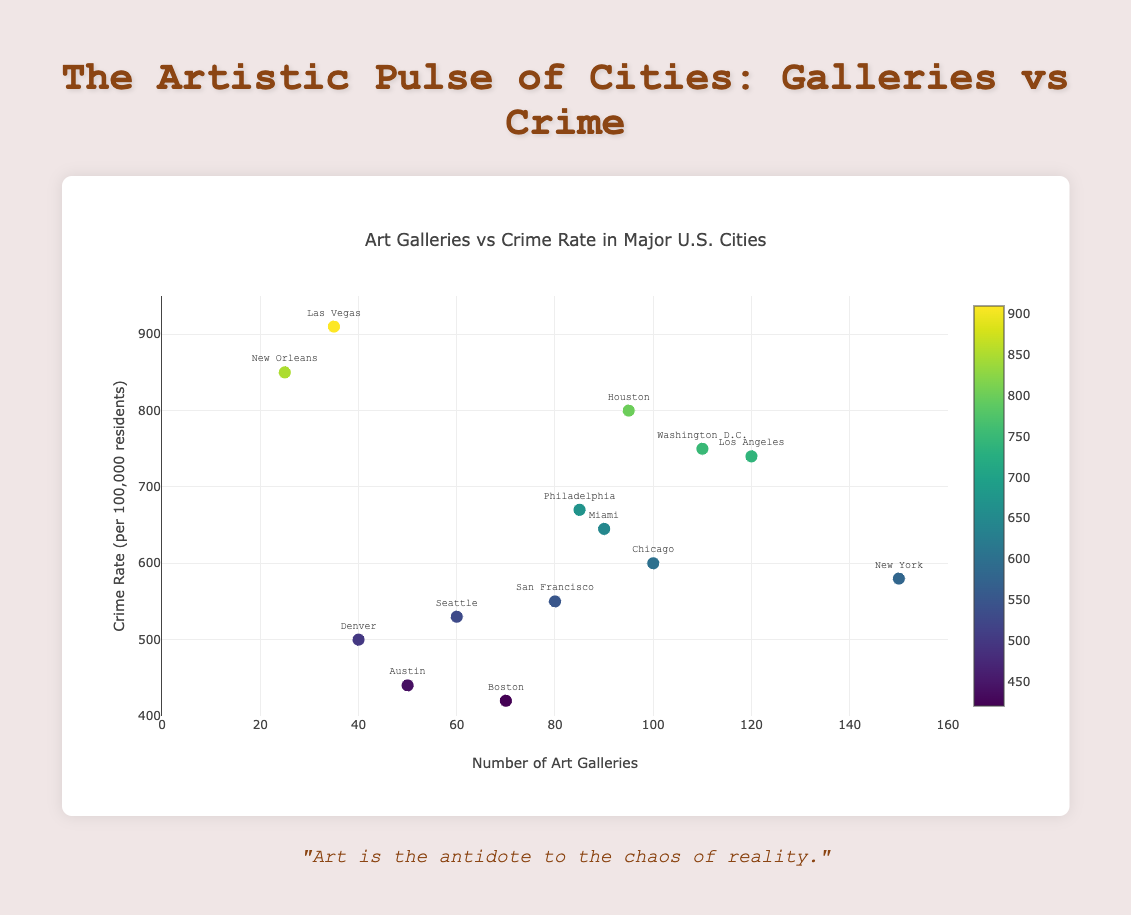What is the title of the plot? The title of the plot is generally located at the top of the figure and provides an overview of what the data represents.
Answer: Art Galleries vs Crime Rate in Major U.S. Cities Which city has the highest crime rate? By looking at the y-axis in the figure and identifying the highest point, then cross-referencing the associated city, you can determine which city has the highest crime rate.
Answer: Las Vegas How many art galleries are there in New York? Locate the data point labeled "New York" and reference its position along the x-axis which represents the number of art galleries.
Answer: 150 What is the general trend between the number of art galleries and crime rate? Observe the trend line overlaid on the scatter plot. This line provides insight into the overall direction of the data points, helping to identify whether there's a positive or negative correlation.
Answer: Negative correlation Which city has more art galleries, Seattle or Austin? Identify the data points for Seattle and Austin and compare their positions on the x-axis (number of art galleries).
Answer: Seattle If a city has around 50 art galleries, what is its approximate crime rate based on the trend line? Look where the x value is 50 on the trend line and see what y value it corresponds to. This method uses the trend line to make an estimation.
Answer: Approximately 440 What is the average number of art galleries across all cities? Sum all the values for art galleries and divide by the number of cities to find the average.
Answer: (150 + 120 + 100 + 80 + 90 + 70 + 60 + 50 + 40 + 95 + 85 + 110 + 35 + 25) / 14 = ~82.14 Which city has a lower crime rate, Boston or Miami? Compare the data points for Boston and Miami on the y-axis, which indicates the crime rate.
Answer: Boston Do cities with fewer than 60 art galleries tend to have higher or lower crime rates? Identify the data points corresponding to fewer than 60 art galleries and observe their positions on the y-axis to determine if the crime rates are generally higher or lower.
Answer: Generally higher 